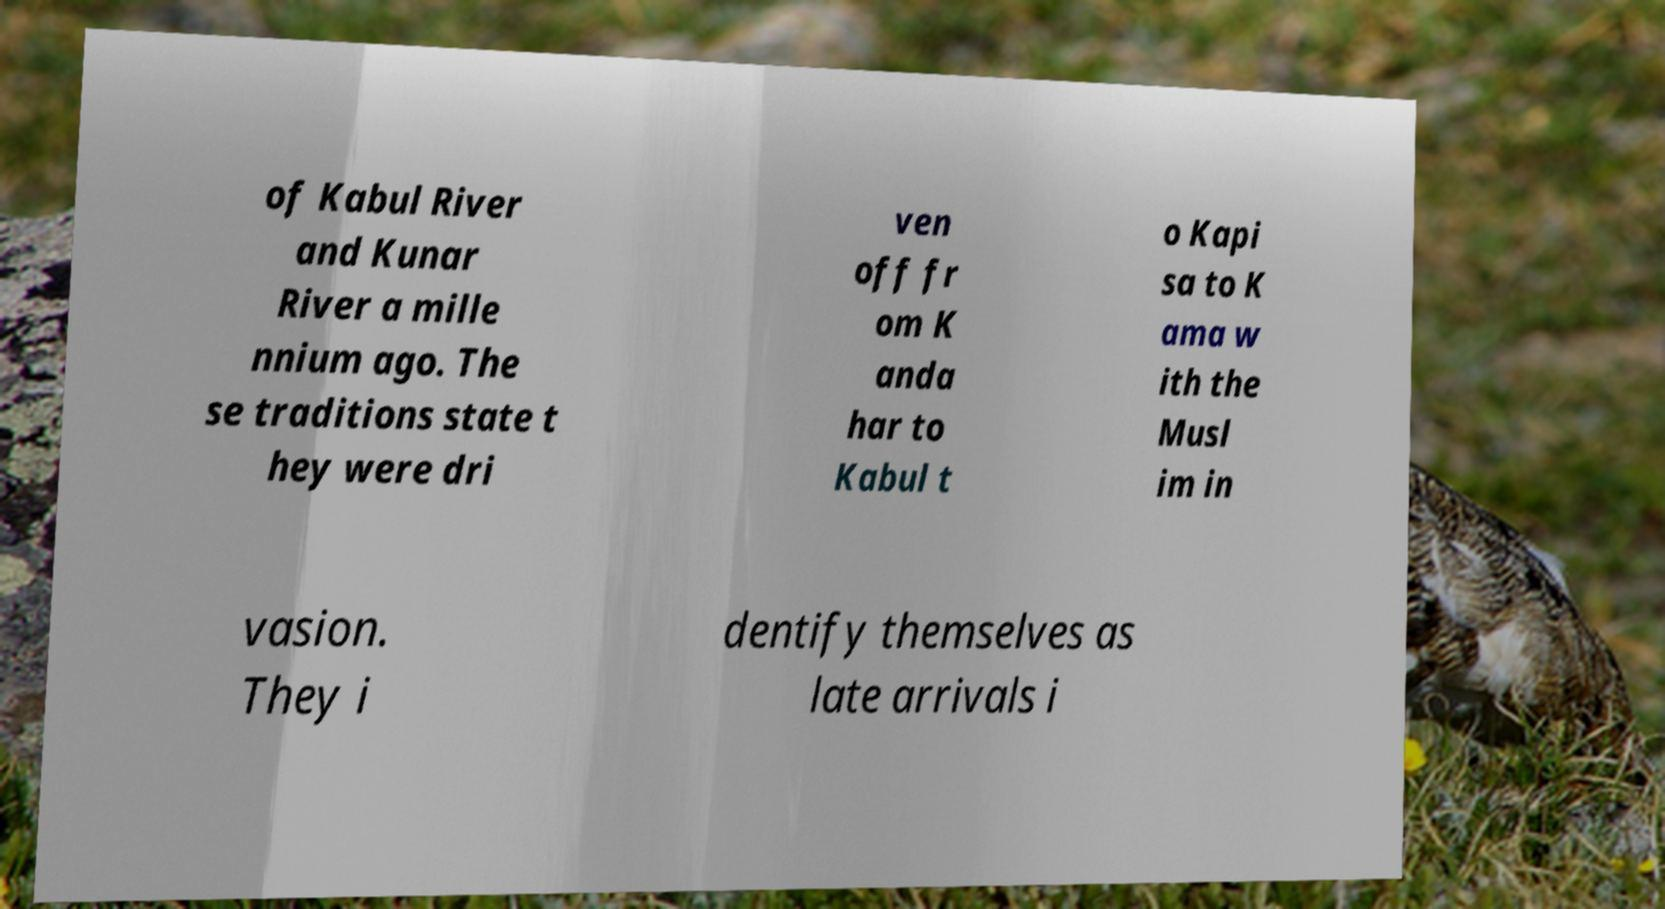There's text embedded in this image that I need extracted. Can you transcribe it verbatim? of Kabul River and Kunar River a mille nnium ago. The se traditions state t hey were dri ven off fr om K anda har to Kabul t o Kapi sa to K ama w ith the Musl im in vasion. They i dentify themselves as late arrivals i 